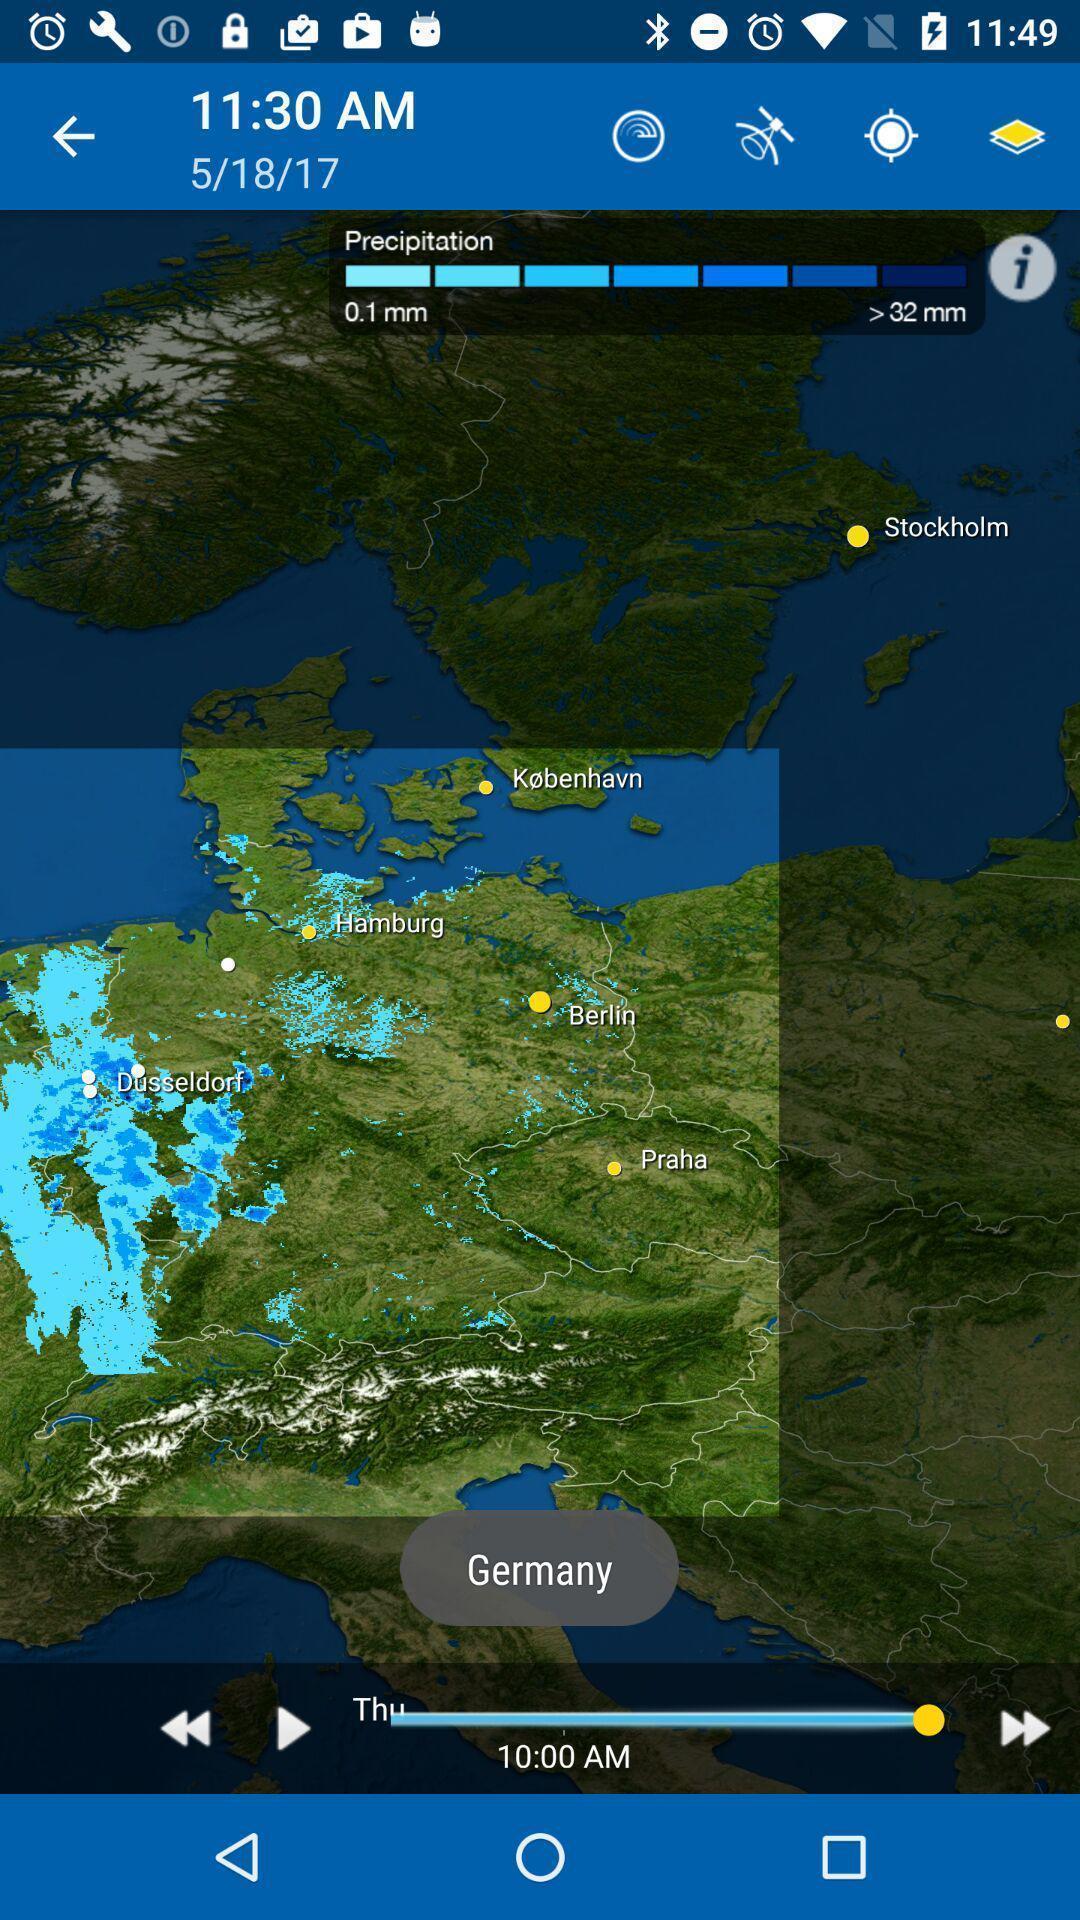Provide a detailed account of this screenshot. Time and date page of a map. 